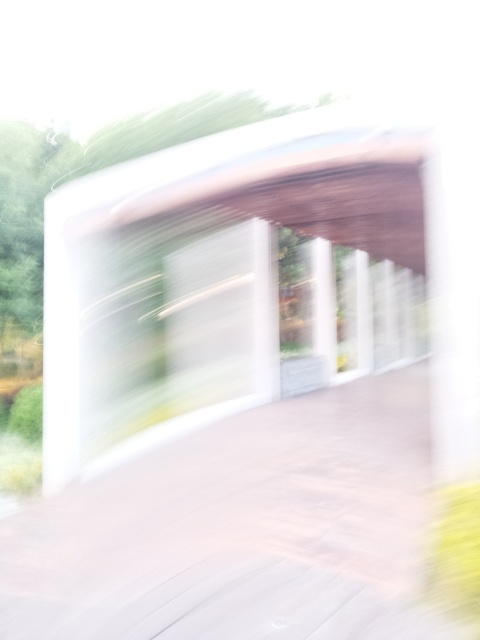Can you speculate what might have caused the blurriness in this image? The blurriness in the image could be a result of several factors, such as camera shake during exposure, a slow shutter speed not suitable for the motion of the subject or the camera, or even an incorrect focus setting. It might also be an intentional artistic effect to convey motion or a dream-like quality. 